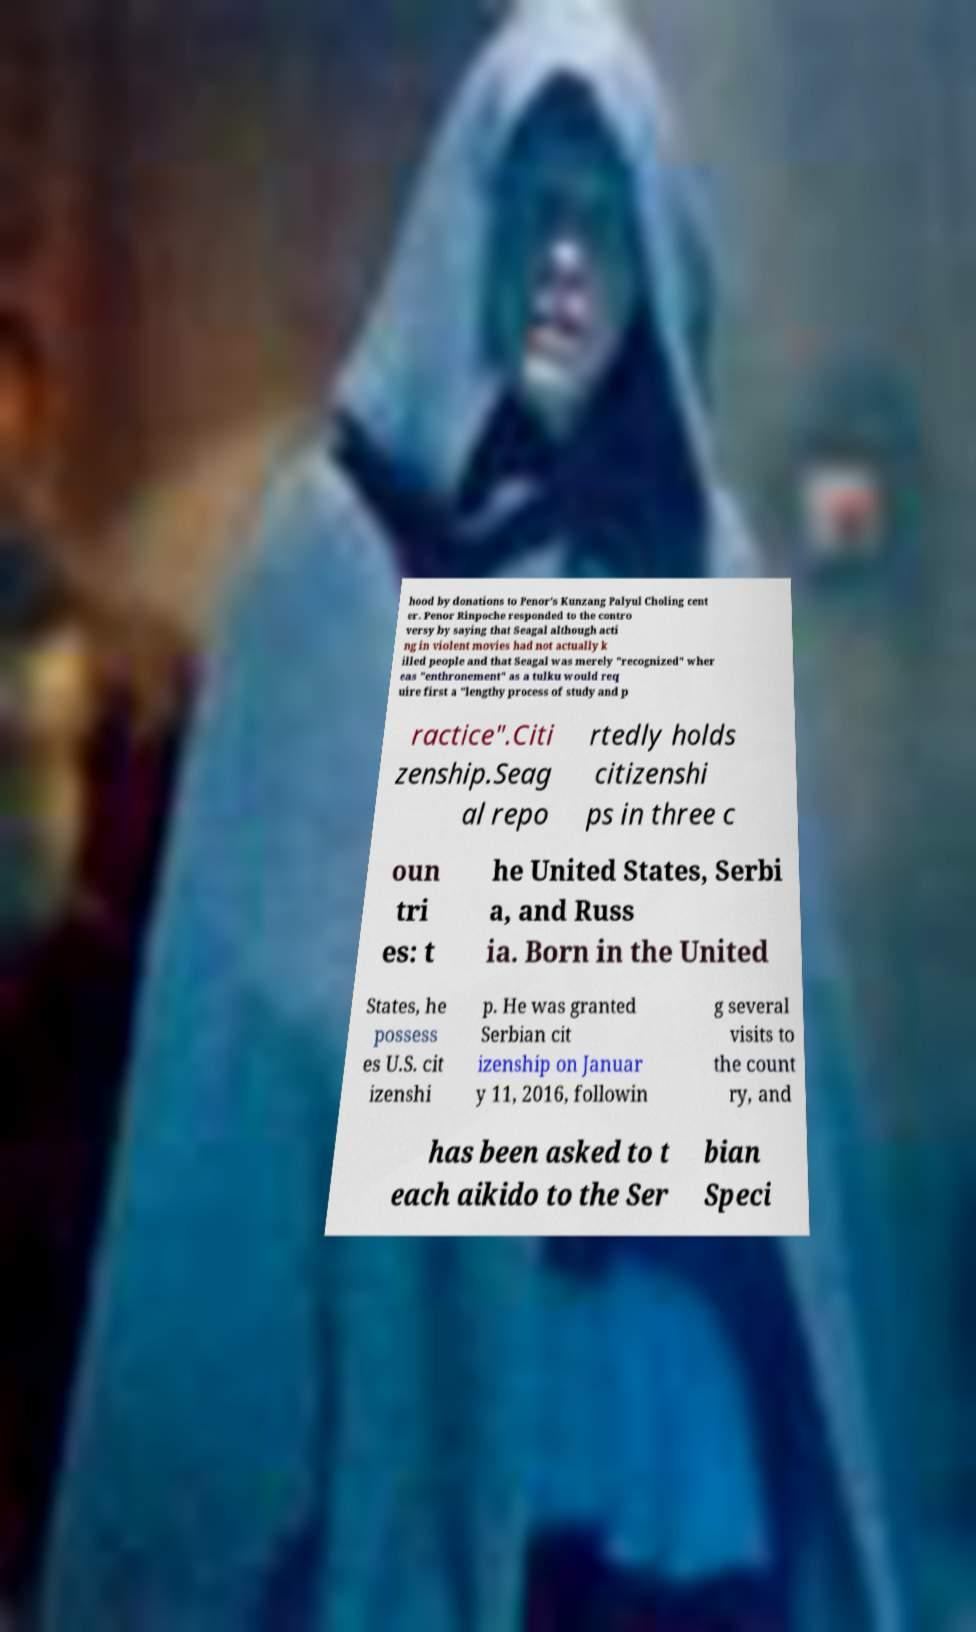I need the written content from this picture converted into text. Can you do that? hood by donations to Penor's Kunzang Palyul Choling cent er. Penor Rinpoche responded to the contro versy by saying that Seagal although acti ng in violent movies had not actually k illed people and that Seagal was merely "recognized" wher eas "enthronement" as a tulku would req uire first a "lengthy process of study and p ractice".Citi zenship.Seag al repo rtedly holds citizenshi ps in three c oun tri es: t he United States, Serbi a, and Russ ia. Born in the United States, he possess es U.S. cit izenshi p. He was granted Serbian cit izenship on Januar y 11, 2016, followin g several visits to the count ry, and has been asked to t each aikido to the Ser bian Speci 